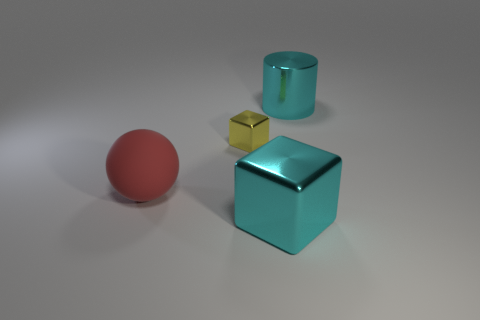Add 1 big purple balls. How many objects exist? 5 Add 2 metal blocks. How many metal blocks exist? 4 Subtract 0 blue balls. How many objects are left? 4 Subtract all cylinders. How many objects are left? 3 Subtract all metallic cylinders. Subtract all brown rubber cylinders. How many objects are left? 3 Add 4 tiny shiny objects. How many tiny shiny objects are left? 5 